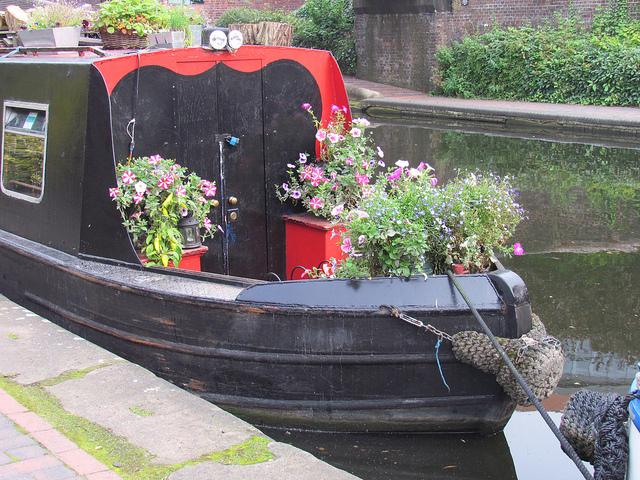Are there any people on the boat?
Keep it brief. No. What color are the flowers?
Short answer required. Pink. Is the boat tied securely?
Short answer required. Yes. 